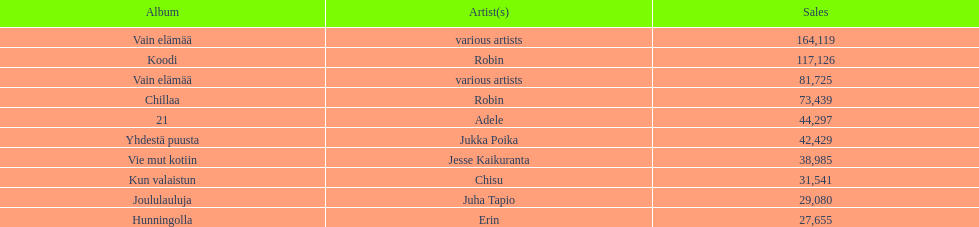What's the combined sales count for the top 10 best-selling albums? 650396. Parse the full table. {'header': ['Album', 'Artist(s)', 'Sales'], 'rows': [['Vain elämää', 'various artists', '164,119'], ['Koodi', 'Robin', '117,126'], ['Vain elämää', 'various artists', '81,725'], ['Chillaa', 'Robin', '73,439'], ['21', 'Adele', '44,297'], ['Yhdestä puusta', 'Jukka Poika', '42,429'], ['Vie mut kotiin', 'Jesse Kaikuranta', '38,985'], ['Kun valaistun', 'Chisu', '31,541'], ['Joululauluja', 'Juha Tapio', '29,080'], ['Hunningolla', 'Erin', '27,655']]} 